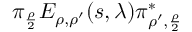Convert formula to latex. <formula><loc_0><loc_0><loc_500><loc_500>\pi _ { \frac { \rho } { 2 } } E _ { \rho , \rho ^ { \prime } } ( s , \lambda ) \pi _ { \rho ^ { \prime } , \frac { \rho } { 2 } } ^ { * }</formula> 